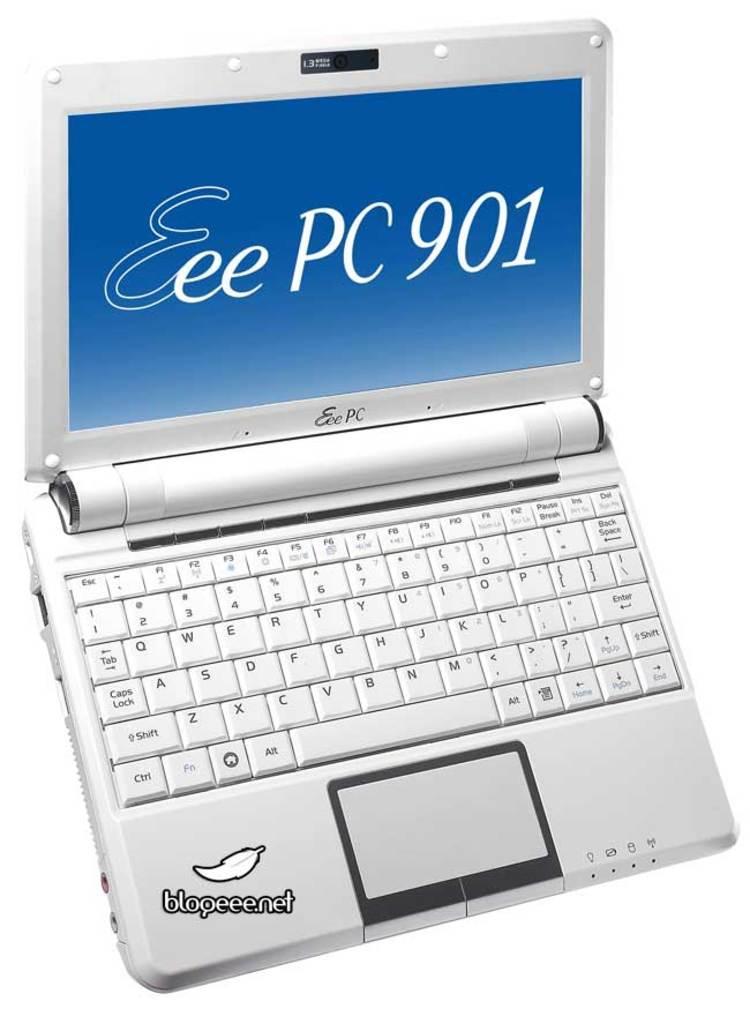<image>
Give a short and clear explanation of the subsequent image. a computer screen that says 'eee pc 901' on it 